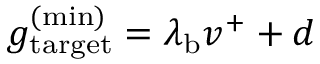<formula> <loc_0><loc_0><loc_500><loc_500>g _ { t \arg e t } ^ { ( \min ) } = \lambda _ { b } v ^ { + } + d</formula> 